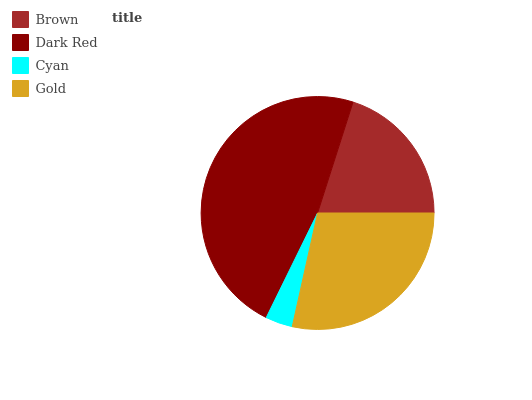Is Cyan the minimum?
Answer yes or no. Yes. Is Dark Red the maximum?
Answer yes or no. Yes. Is Dark Red the minimum?
Answer yes or no. No. Is Cyan the maximum?
Answer yes or no. No. Is Dark Red greater than Cyan?
Answer yes or no. Yes. Is Cyan less than Dark Red?
Answer yes or no. Yes. Is Cyan greater than Dark Red?
Answer yes or no. No. Is Dark Red less than Cyan?
Answer yes or no. No. Is Gold the high median?
Answer yes or no. Yes. Is Brown the low median?
Answer yes or no. Yes. Is Dark Red the high median?
Answer yes or no. No. Is Cyan the low median?
Answer yes or no. No. 